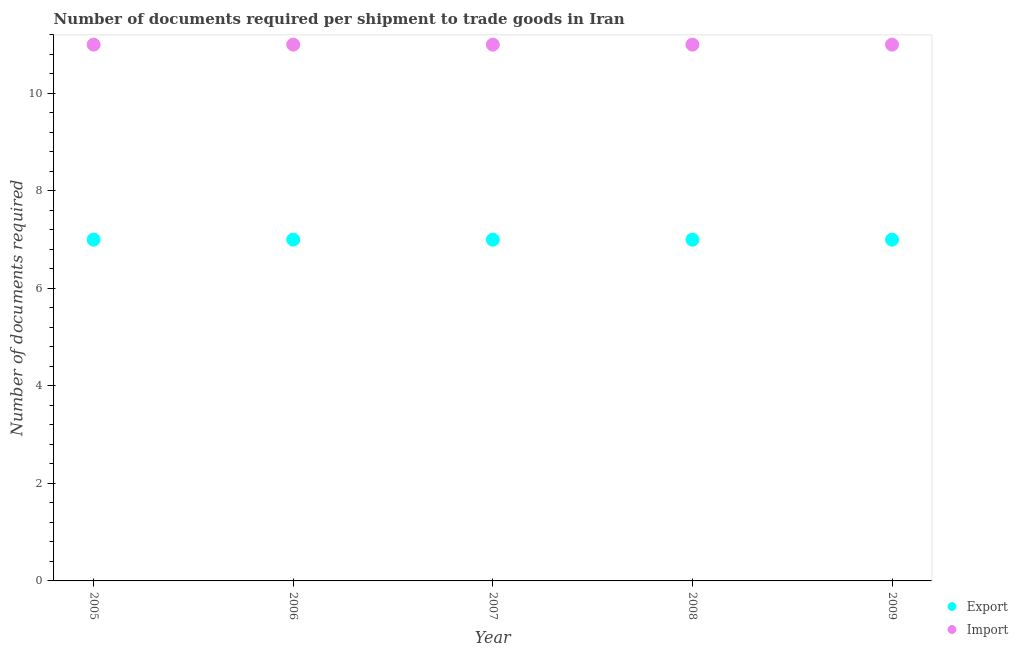How many different coloured dotlines are there?
Ensure brevity in your answer.  2. Is the number of dotlines equal to the number of legend labels?
Keep it short and to the point. Yes. What is the number of documents required to export goods in 2009?
Offer a very short reply. 7. Across all years, what is the maximum number of documents required to export goods?
Make the answer very short. 7. Across all years, what is the minimum number of documents required to export goods?
Your answer should be compact. 7. In which year was the number of documents required to import goods minimum?
Offer a very short reply. 2005. What is the total number of documents required to import goods in the graph?
Give a very brief answer. 55. What is the difference between the number of documents required to export goods in 2009 and the number of documents required to import goods in 2005?
Offer a very short reply. -4. What is the average number of documents required to import goods per year?
Your answer should be very brief. 11. In the year 2009, what is the difference between the number of documents required to export goods and number of documents required to import goods?
Make the answer very short. -4. In how many years, is the number of documents required to import goods greater than 2.4?
Your response must be concise. 5. What is the ratio of the number of documents required to export goods in 2006 to that in 2008?
Your answer should be compact. 1. What is the difference between the highest and the lowest number of documents required to export goods?
Keep it short and to the point. 0. Is the sum of the number of documents required to export goods in 2006 and 2009 greater than the maximum number of documents required to import goods across all years?
Make the answer very short. Yes. How many years are there in the graph?
Keep it short and to the point. 5. Are the values on the major ticks of Y-axis written in scientific E-notation?
Give a very brief answer. No. Does the graph contain grids?
Provide a short and direct response. No. Where does the legend appear in the graph?
Offer a very short reply. Bottom right. How many legend labels are there?
Keep it short and to the point. 2. What is the title of the graph?
Ensure brevity in your answer.  Number of documents required per shipment to trade goods in Iran. Does "IMF concessional" appear as one of the legend labels in the graph?
Offer a terse response. No. What is the label or title of the X-axis?
Your answer should be compact. Year. What is the label or title of the Y-axis?
Your answer should be very brief. Number of documents required. What is the Number of documents required in Export in 2005?
Ensure brevity in your answer.  7. What is the Number of documents required in Import in 2005?
Offer a terse response. 11. What is the Number of documents required of Export in 2006?
Provide a short and direct response. 7. What is the Number of documents required in Export in 2007?
Give a very brief answer. 7. What is the Number of documents required of Import in 2008?
Give a very brief answer. 11. Across all years, what is the maximum Number of documents required in Export?
Offer a terse response. 7. Across all years, what is the minimum Number of documents required of Import?
Offer a terse response. 11. What is the difference between the Number of documents required of Export in 2005 and that in 2006?
Make the answer very short. 0. What is the difference between the Number of documents required in Export in 2005 and that in 2007?
Offer a terse response. 0. What is the difference between the Number of documents required of Import in 2005 and that in 2007?
Your response must be concise. 0. What is the difference between the Number of documents required of Import in 2005 and that in 2009?
Your answer should be very brief. 0. What is the difference between the Number of documents required of Export in 2006 and that in 2007?
Make the answer very short. 0. What is the difference between the Number of documents required in Import in 2006 and that in 2007?
Provide a short and direct response. 0. What is the difference between the Number of documents required of Export in 2006 and that in 2008?
Your response must be concise. 0. What is the difference between the Number of documents required of Import in 2006 and that in 2008?
Give a very brief answer. 0. What is the difference between the Number of documents required in Export in 2006 and that in 2009?
Give a very brief answer. 0. What is the difference between the Number of documents required of Import in 2006 and that in 2009?
Ensure brevity in your answer.  0. What is the difference between the Number of documents required in Export in 2007 and that in 2008?
Provide a short and direct response. 0. What is the difference between the Number of documents required of Import in 2007 and that in 2008?
Make the answer very short. 0. What is the difference between the Number of documents required of Export in 2007 and that in 2009?
Your answer should be compact. 0. What is the difference between the Number of documents required in Import in 2007 and that in 2009?
Provide a succinct answer. 0. What is the difference between the Number of documents required in Import in 2008 and that in 2009?
Offer a terse response. 0. What is the difference between the Number of documents required in Export in 2005 and the Number of documents required in Import in 2006?
Offer a very short reply. -4. What is the difference between the Number of documents required of Export in 2005 and the Number of documents required of Import in 2007?
Provide a succinct answer. -4. What is the difference between the Number of documents required in Export in 2005 and the Number of documents required in Import in 2008?
Ensure brevity in your answer.  -4. What is the difference between the Number of documents required of Export in 2006 and the Number of documents required of Import in 2008?
Provide a succinct answer. -4. What is the difference between the Number of documents required of Export in 2007 and the Number of documents required of Import in 2008?
Keep it short and to the point. -4. What is the difference between the Number of documents required of Export in 2008 and the Number of documents required of Import in 2009?
Your response must be concise. -4. What is the average Number of documents required in Export per year?
Give a very brief answer. 7. In the year 2007, what is the difference between the Number of documents required of Export and Number of documents required of Import?
Provide a short and direct response. -4. In the year 2008, what is the difference between the Number of documents required of Export and Number of documents required of Import?
Keep it short and to the point. -4. What is the ratio of the Number of documents required of Export in 2005 to that in 2007?
Ensure brevity in your answer.  1. What is the ratio of the Number of documents required in Import in 2005 to that in 2007?
Provide a short and direct response. 1. What is the ratio of the Number of documents required of Export in 2005 to that in 2009?
Your answer should be very brief. 1. What is the ratio of the Number of documents required of Import in 2005 to that in 2009?
Provide a succinct answer. 1. What is the ratio of the Number of documents required of Export in 2006 to that in 2007?
Give a very brief answer. 1. What is the ratio of the Number of documents required in Import in 2006 to that in 2007?
Your response must be concise. 1. What is the ratio of the Number of documents required of Import in 2006 to that in 2008?
Give a very brief answer. 1. What is the ratio of the Number of documents required of Export in 2006 to that in 2009?
Ensure brevity in your answer.  1. What is the ratio of the Number of documents required of Import in 2007 to that in 2008?
Offer a terse response. 1. What is the ratio of the Number of documents required of Export in 2008 to that in 2009?
Offer a very short reply. 1. What is the ratio of the Number of documents required in Import in 2008 to that in 2009?
Ensure brevity in your answer.  1. What is the difference between the highest and the second highest Number of documents required of Export?
Keep it short and to the point. 0. What is the difference between the highest and the second highest Number of documents required of Import?
Keep it short and to the point. 0. 